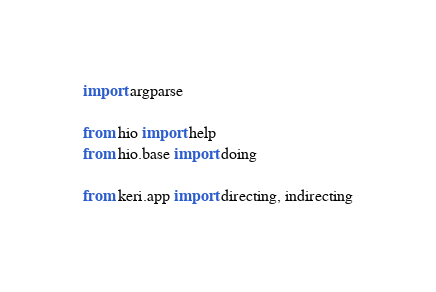<code> <loc_0><loc_0><loc_500><loc_500><_Python_>import argparse

from hio import help
from hio.base import doing

from keri.app import directing, indirecting</code> 